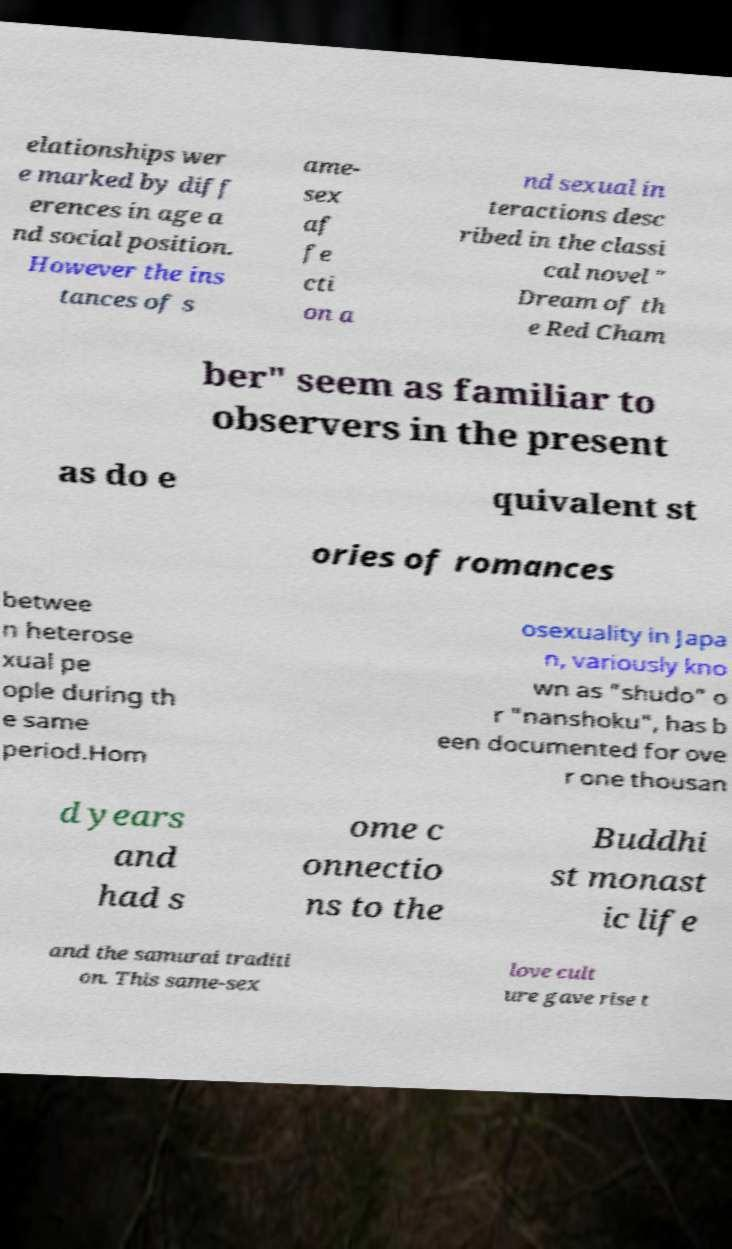Could you assist in decoding the text presented in this image and type it out clearly? elationships wer e marked by diff erences in age a nd social position. However the ins tances of s ame- sex af fe cti on a nd sexual in teractions desc ribed in the classi cal novel " Dream of th e Red Cham ber" seem as familiar to observers in the present as do e quivalent st ories of romances betwee n heterose xual pe ople during th e same period.Hom osexuality in Japa n, variously kno wn as "shudo" o r "nanshoku", has b een documented for ove r one thousan d years and had s ome c onnectio ns to the Buddhi st monast ic life and the samurai traditi on. This same-sex love cult ure gave rise t 